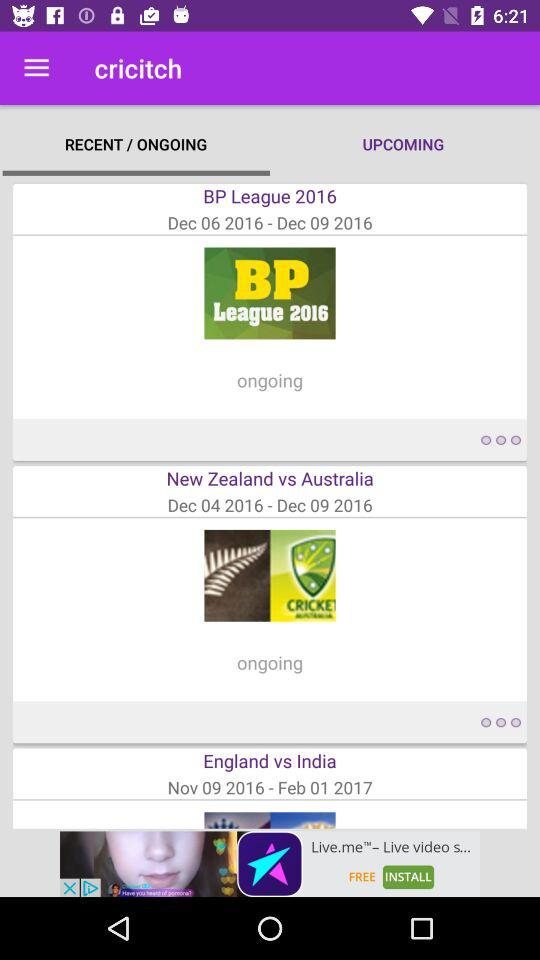What is the start date of the "India" vs. "England" series? The start date is November 9, 2016. 